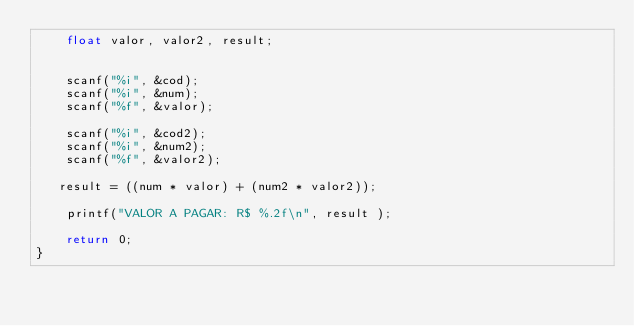<code> <loc_0><loc_0><loc_500><loc_500><_C_>	float valor, valor2, result;
    

    scanf("%i", &cod);
    scanf("%i", &num);
    scanf("%f", &valor);
    
    scanf("%i", &cod2);
    scanf("%i", &num2);
    scanf("%f", &valor2);
    
   result = ((num * valor) + (num2 * valor2));
   
    printf("VALOR A PAGAR: R$ %.2f\n", result );
 
    return 0;
}

</code> 